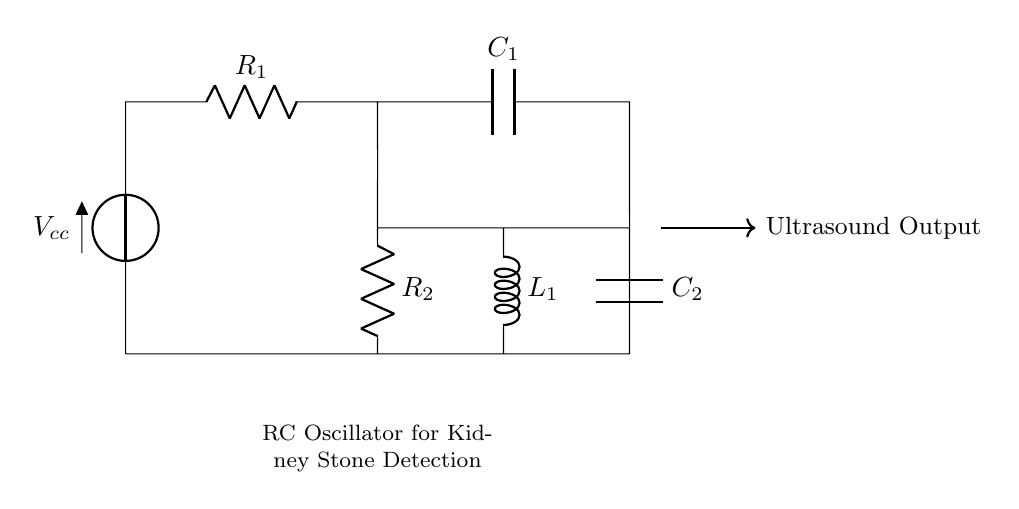What is the total number of resistors in the circuit? The circuit diagram shows two resistors labeled as R1 and R2, indicating that there are two resistors in total.
Answer: Two What type of circuit is depicted here? The circuit is identified as an RC oscillator circuit, which uses resistors and capacitors to generate oscillating signals for ultrasound applications.
Answer: RC oscillator What component is generating the ultrasound output? The ultrasound output is connected at the node right of C2, indicating that C2 is involved in generating the output.
Answer: C2 What is the purpose of the inductor in this circuit? The inductor (L1) is included in the circuit configuration, which typically works alongside resistors and capacitors to affect the frequency of oscillation.
Answer: Frequency tuning What does the voltage Vcc represent? Vcc is the input voltage supply for the entire circuit, providing the potential difference needed for the components to operate.
Answer: Supply voltage How are the capacitors connected in the circuit? The capacitors C1 and C2 are connected in parallel with the resistors, influencing the timing and frequency characteristics of the oscillator circuit.
Answer: Parallel What would happen if one of the resistors was removed? Removing a resistor would alter the resistance values, potentially changing the oscillation frequency and affecting the circuit's performance.
Answer: Altered frequency 